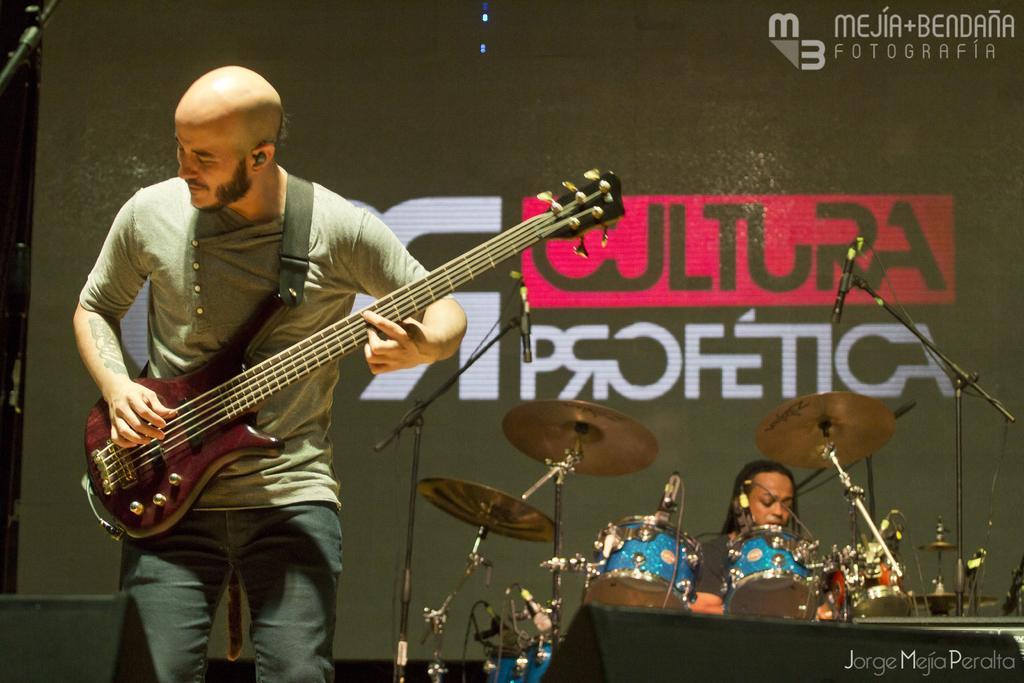In one or two sentences, can you explain what this image depicts? In this image there are two persons at the left side of the image there is a person wearing T-shirt playing guitar and at the right side of the image there is a person beating drums and at the background there is a black color sheet. 